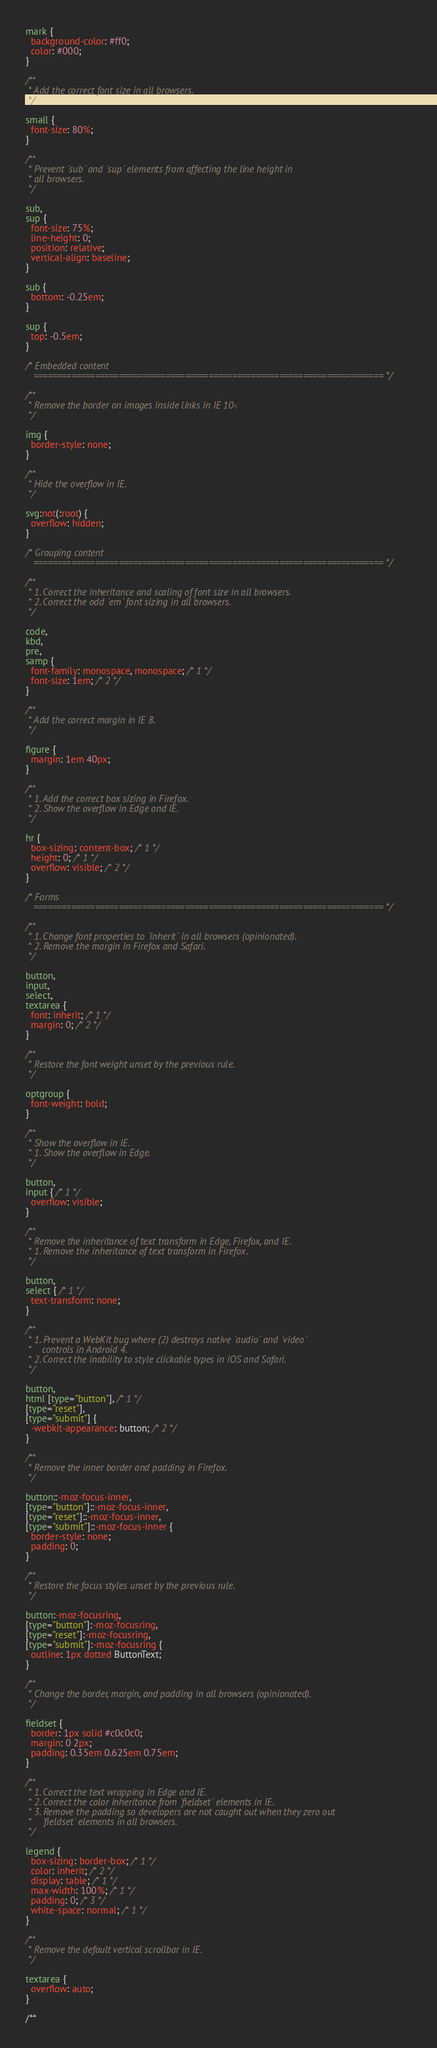Convert code to text. <code><loc_0><loc_0><loc_500><loc_500><_CSS_>
mark {
  background-color: #ff0;
  color: #000;
}

/**
 * Add the correct font size in all browsers.
 */

small {
  font-size: 80%;
}

/**
 * Prevent `sub` and `sup` elements from affecting the line height in
 * all browsers.
 */

sub,
sup {
  font-size: 75%;
  line-height: 0;
  position: relative;
  vertical-align: baseline;
}

sub {
  bottom: -0.25em;
}

sup {
  top: -0.5em;
}

/* Embedded content
   ========================================================================== */

/**
 * Remove the border on images inside links in IE 10-.
 */

img {
  border-style: none;
}

/**
 * Hide the overflow in IE.
 */

svg:not(:root) {
  overflow: hidden;
}

/* Grouping content
   ========================================================================== */

/**
 * 1. Correct the inheritance and scaling of font size in all browsers.
 * 2. Correct the odd `em` font sizing in all browsers.
 */

code,
kbd,
pre,
samp {
  font-family: monospace, monospace; /* 1 */
  font-size: 1em; /* 2 */
}

/**
 * Add the correct margin in IE 8.
 */

figure {
  margin: 1em 40px;
}

/**
 * 1. Add the correct box sizing in Firefox.
 * 2. Show the overflow in Edge and IE.
 */

hr {
  box-sizing: content-box; /* 1 */
  height: 0; /* 1 */
  overflow: visible; /* 2 */
}

/* Forms
   ========================================================================== */

/**
 * 1. Change font properties to `inherit` in all browsers (opinionated).
 * 2. Remove the margin in Firefox and Safari.
 */

button,
input,
select,
textarea {
  font: inherit; /* 1 */
  margin: 0; /* 2 */
}

/**
 * Restore the font weight unset by the previous rule.
 */

optgroup {
  font-weight: bold;
}

/**
 * Show the overflow in IE.
 * 1. Show the overflow in Edge.
 */

button,
input { /* 1 */
  overflow: visible;
}

/**
 * Remove the inheritance of text transform in Edge, Firefox, and IE.
 * 1. Remove the inheritance of text transform in Firefox.
 */

button,
select { /* 1 */
  text-transform: none;
}

/**
 * 1. Prevent a WebKit bug where (2) destroys native `audio` and `video`
 *    controls in Android 4.
 * 2. Correct the inability to style clickable types in iOS and Safari.
 */

button,
html [type="button"], /* 1 */
[type="reset"],
[type="submit"] {
  -webkit-appearance: button; /* 2 */
}

/**
 * Remove the inner border and padding in Firefox.
 */

button::-moz-focus-inner,
[type="button"]::-moz-focus-inner,
[type="reset"]::-moz-focus-inner,
[type="submit"]::-moz-focus-inner {
  border-style: none;
  padding: 0;
}

/**
 * Restore the focus styles unset by the previous rule.
 */

button:-moz-focusring,
[type="button"]:-moz-focusring,
[type="reset"]:-moz-focusring,
[type="submit"]:-moz-focusring {
  outline: 1px dotted ButtonText;
}

/**
 * Change the border, margin, and padding in all browsers (opinionated).
 */

fieldset {
  border: 1px solid #c0c0c0;
  margin: 0 2px;
  padding: 0.35em 0.625em 0.75em;
}

/**
 * 1. Correct the text wrapping in Edge and IE.
 * 2. Correct the color inheritance from `fieldset` elements in IE.
 * 3. Remove the padding so developers are not caught out when they zero out
 *    `fieldset` elements in all browsers.
 */

legend {
  box-sizing: border-box; /* 1 */
  color: inherit; /* 2 */
  display: table; /* 1 */
  max-width: 100%; /* 1 */
  padding: 0; /* 3 */
  white-space: normal; /* 1 */
}

/**
 * Remove the default vertical scrollbar in IE.
 */

textarea {
  overflow: auto;
}

/**</code> 